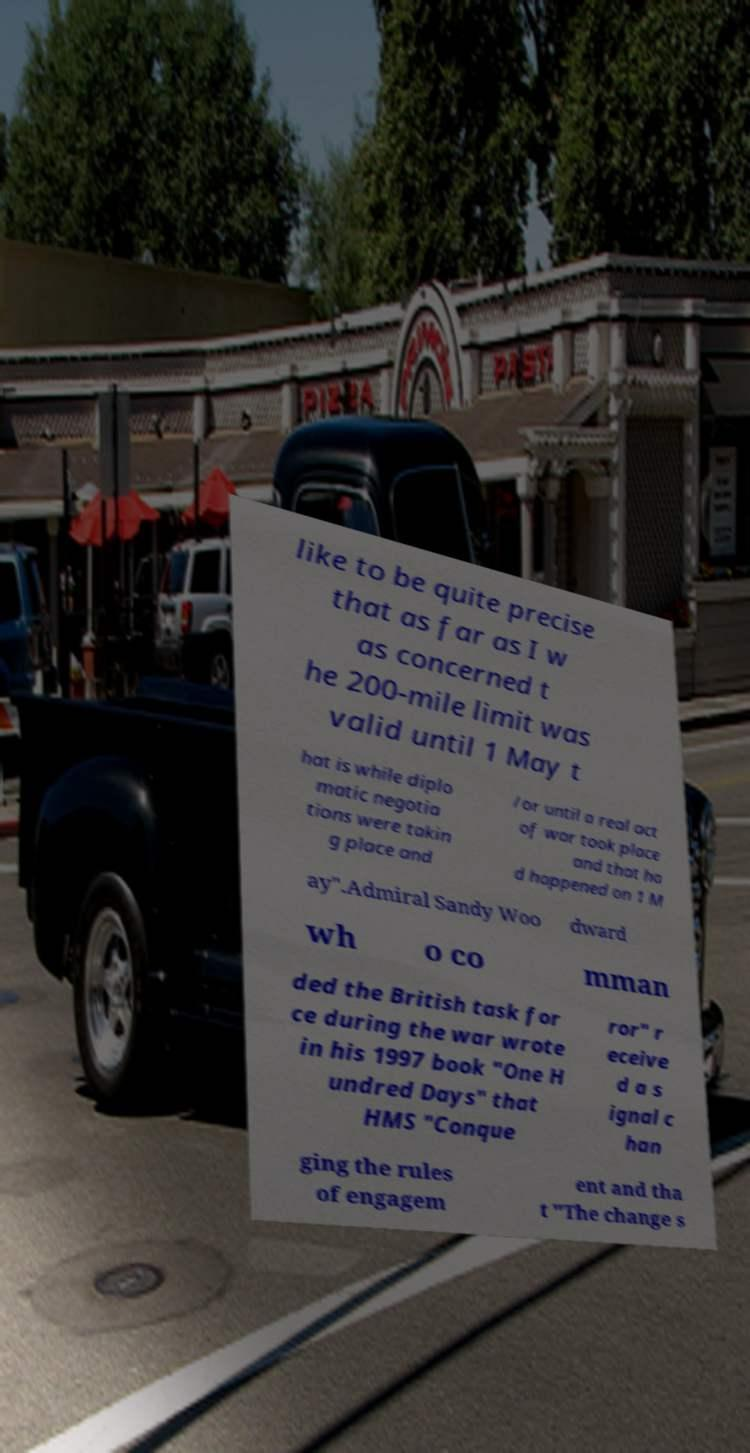For documentation purposes, I need the text within this image transcribed. Could you provide that? like to be quite precise that as far as I w as concerned t he 200-mile limit was valid until 1 May t hat is while diplo matic negotia tions were takin g place and /or until a real act of war took place and that ha d happened on 1 M ay".Admiral Sandy Woo dward wh o co mman ded the British task for ce during the war wrote in his 1997 book "One H undred Days" that HMS "Conque ror" r eceive d a s ignal c han ging the rules of engagem ent and tha t "The change s 